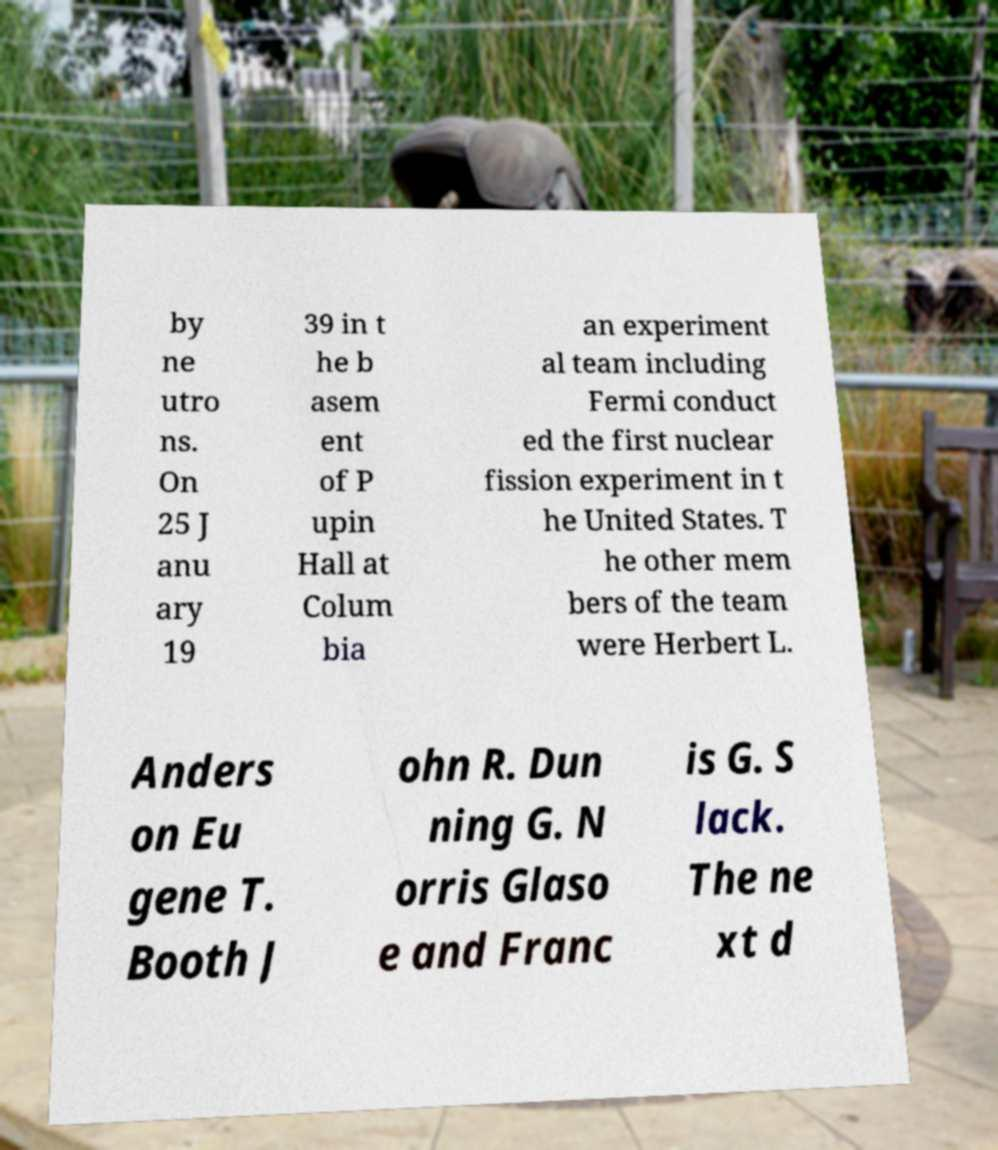There's text embedded in this image that I need extracted. Can you transcribe it verbatim? by ne utro ns. On 25 J anu ary 19 39 in t he b asem ent of P upin Hall at Colum bia an experiment al team including Fermi conduct ed the first nuclear fission experiment in t he United States. T he other mem bers of the team were Herbert L. Anders on Eu gene T. Booth J ohn R. Dun ning G. N orris Glaso e and Franc is G. S lack. The ne xt d 